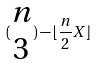Convert formula to latex. <formula><loc_0><loc_0><loc_500><loc_500>( \begin{matrix} n \\ 3 \end{matrix} ) - \lfloor \frac { n } { 2 } X \rfloor</formula> 